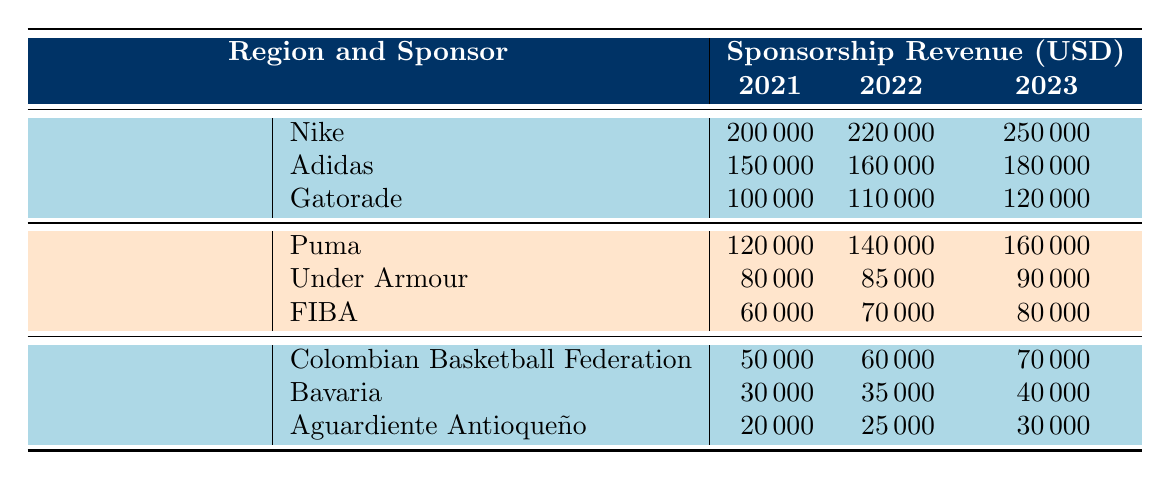What was the sponsorship revenue from Nike in 2021? According to the table, the revenue from Nike in 2021 is listed under North America, which shows a value of 200,000 USD.
Answer: 200000 Which sponsor had the highest revenue in South America in 2022? In 2022, the revenue for the Colombian Basketball Federation is 60,000, Bavaria is 35,000, and Aguardiente Antioqueño is 25,000. The highest among these is from the Colombian Basketball Federation at 60,000 USD.
Answer: Colombian Basketball Federation What was the total sponsorship revenue from all sponsors in North America for 2023? The specific revenues for 2023 under North America are: Nike 250,000, Adidas 180,000, and Gatorade 120,000. Summing these values gives: 250,000 + 180,000 + 120,000 = 550,000 USD.
Answer: 550000 Did the sponsorship revenue from Puma increase every year from 2021 to 2023? According to the table, Puma's revenues are 120,000 in 2021, 140,000 in 2022, and 160,000 in 2023. Since all values are increasing year over year, it confirms the statement.
Answer: Yes What is the average sponsorship revenue from Adidas over the three years? The revenues for Adidas are 150,000 in 2021, 160,000 in 2022, and 180,000 in 2023. The sum is 150,000 + 160,000 + 180,000 = 490,000. To find the average, divide by the number of years: 490,000 / 3 = 163,333.33, which rounds to 163,333.
Answer: 163333.33 